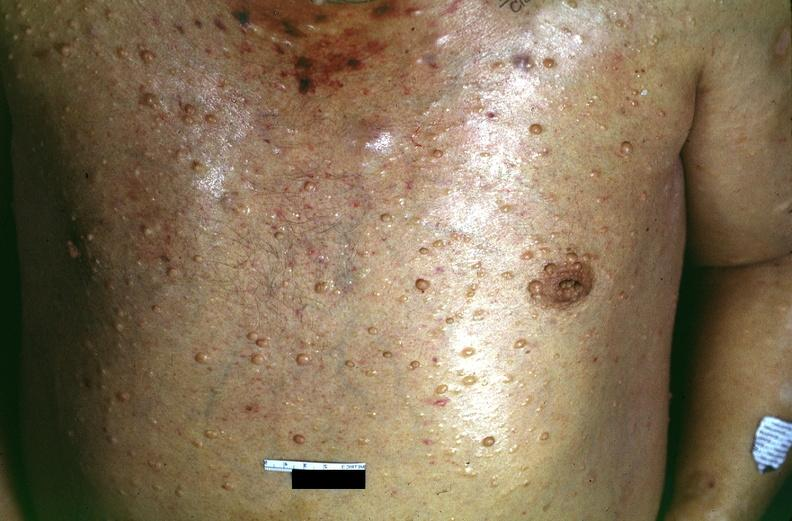does % show skin, neurofibromatosis?
Answer the question using a single word or phrase. No 